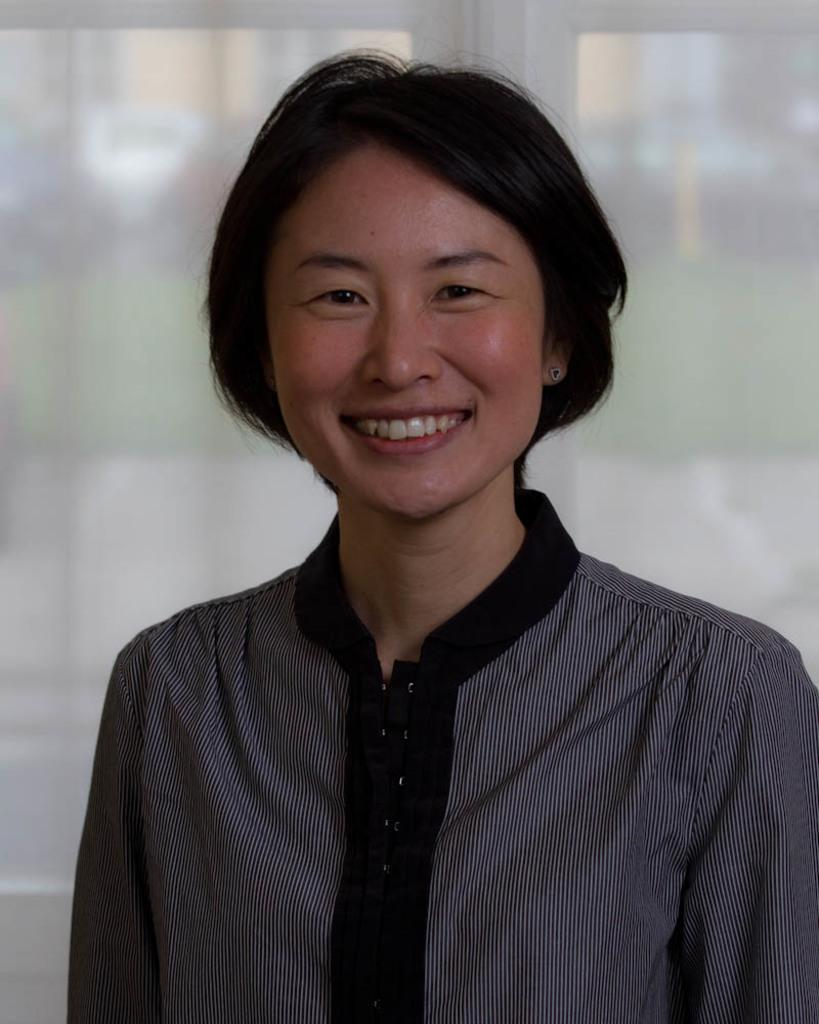What is the main subject of the image? There is a person standing in the image. What is the person's facial expression? The person is smiling. What can be seen in the background of the image? There are windows visible in the background of the image. What type of feast is being prepared on the stove in the image? There is no stove or feast present in the image; it features a person standing and smiling with windows visible in the background. 